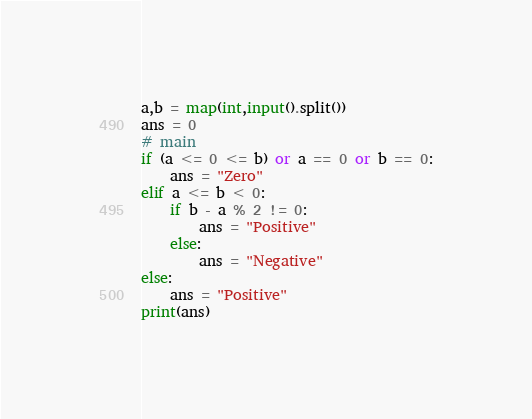<code> <loc_0><loc_0><loc_500><loc_500><_Python_>a,b = map(int,input().split())
ans = 0
# main
if (a <= 0 <= b) or a == 0 or b == 0:
    ans = "Zero"
elif a <= b < 0:
    if b - a % 2 != 0:
        ans = "Positive"
    else:
        ans = "Negative"
else:
    ans = "Positive"
print(ans)</code> 